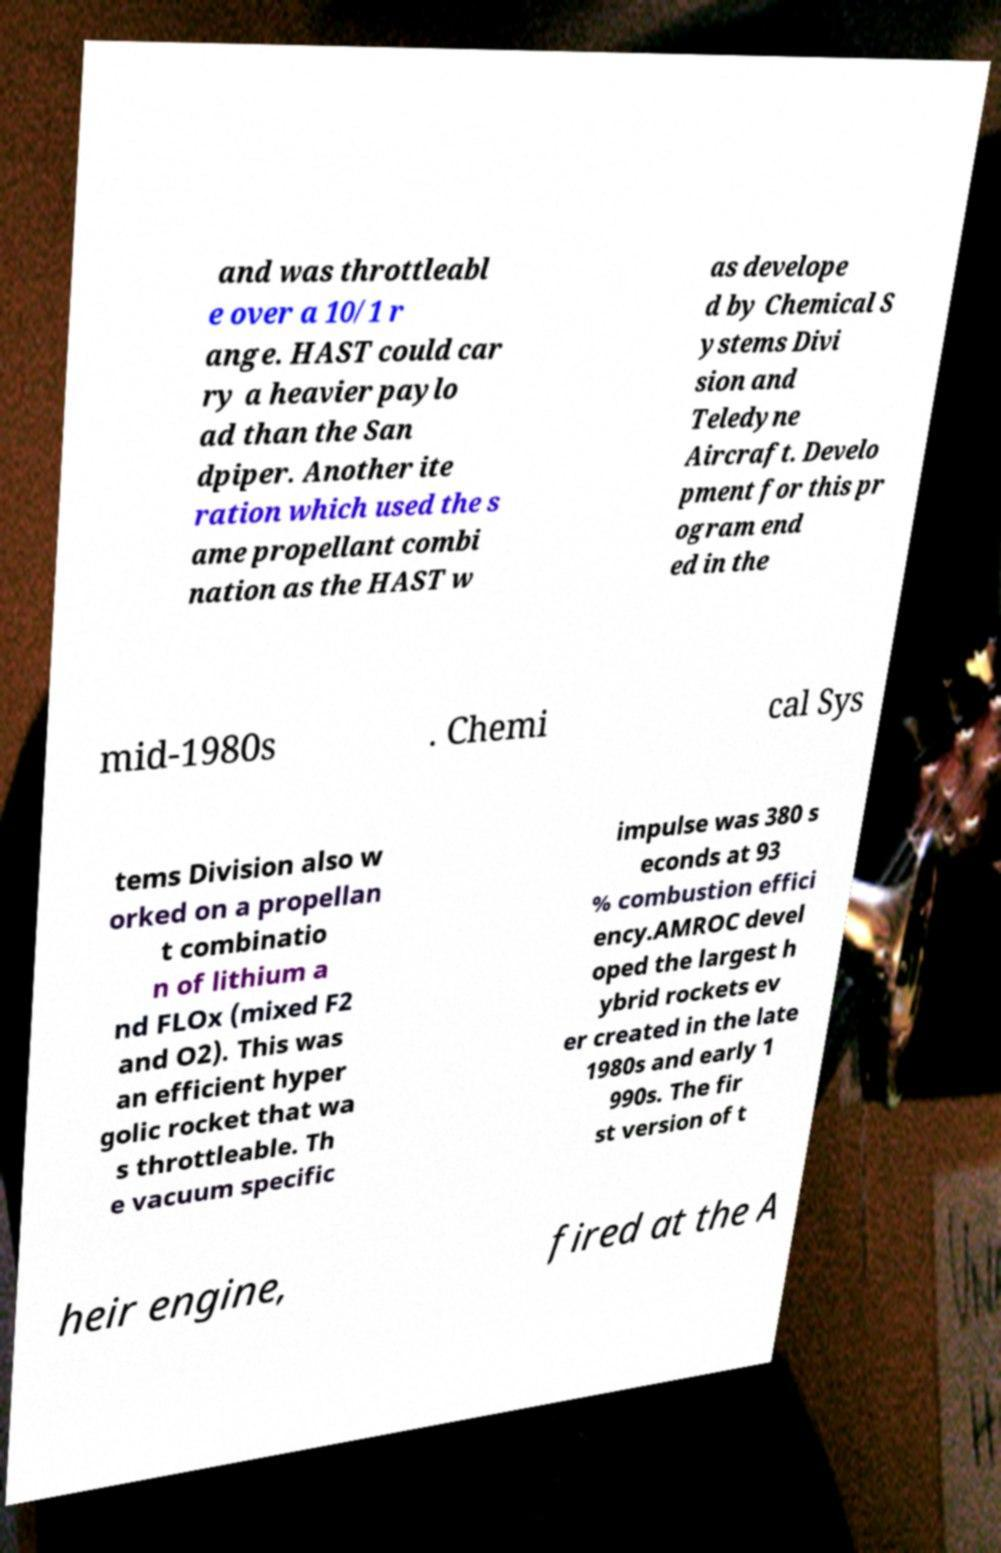For documentation purposes, I need the text within this image transcribed. Could you provide that? and was throttleabl e over a 10/1 r ange. HAST could car ry a heavier paylo ad than the San dpiper. Another ite ration which used the s ame propellant combi nation as the HAST w as develope d by Chemical S ystems Divi sion and Teledyne Aircraft. Develo pment for this pr ogram end ed in the mid-1980s . Chemi cal Sys tems Division also w orked on a propellan t combinatio n of lithium a nd FLOx (mixed F2 and O2). This was an efficient hyper golic rocket that wa s throttleable. Th e vacuum specific impulse was 380 s econds at 93 % combustion effici ency.AMROC devel oped the largest h ybrid rockets ev er created in the late 1980s and early 1 990s. The fir st version of t heir engine, fired at the A 